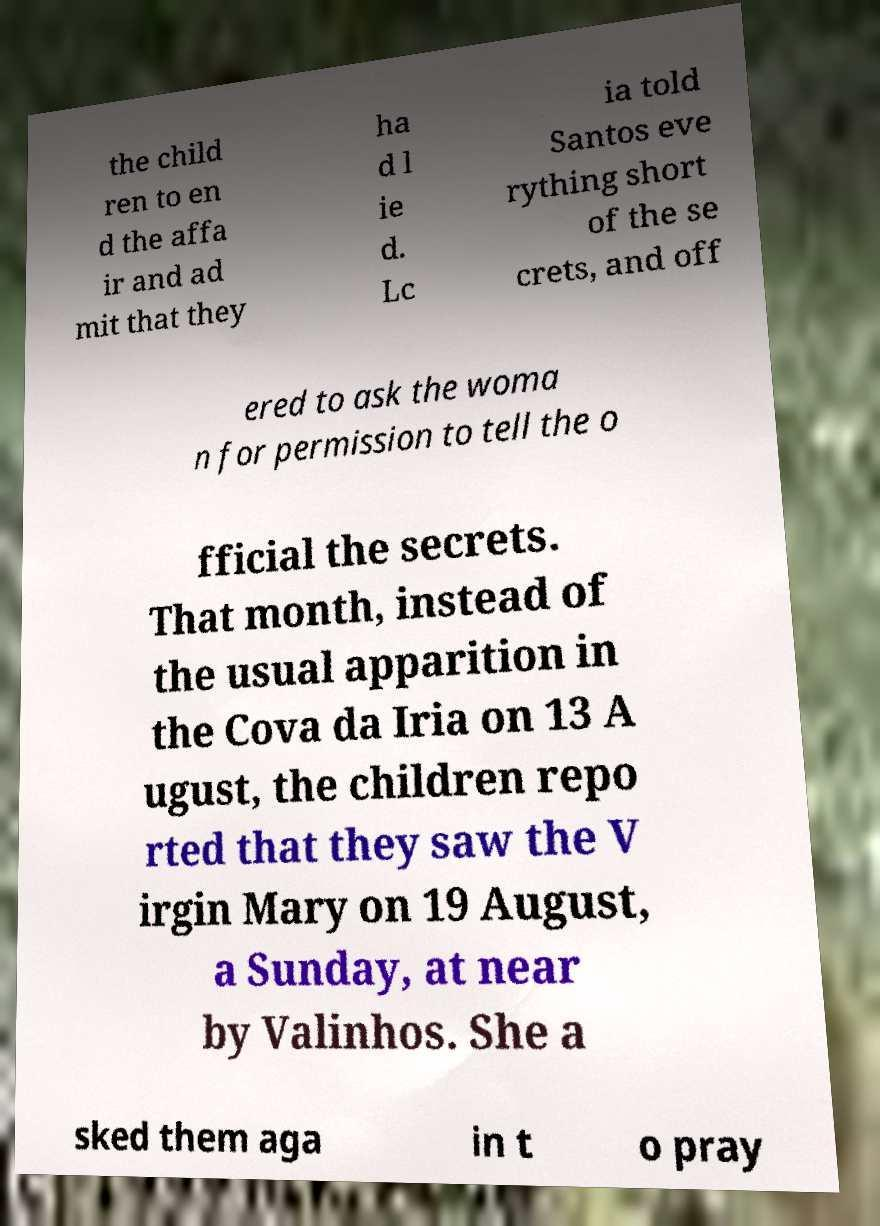What messages or text are displayed in this image? I need them in a readable, typed format. the child ren to en d the affa ir and ad mit that they ha d l ie d. Lc ia told Santos eve rything short of the se crets, and off ered to ask the woma n for permission to tell the o fficial the secrets. That month, instead of the usual apparition in the Cova da Iria on 13 A ugust, the children repo rted that they saw the V irgin Mary on 19 August, a Sunday, at near by Valinhos. She a sked them aga in t o pray 